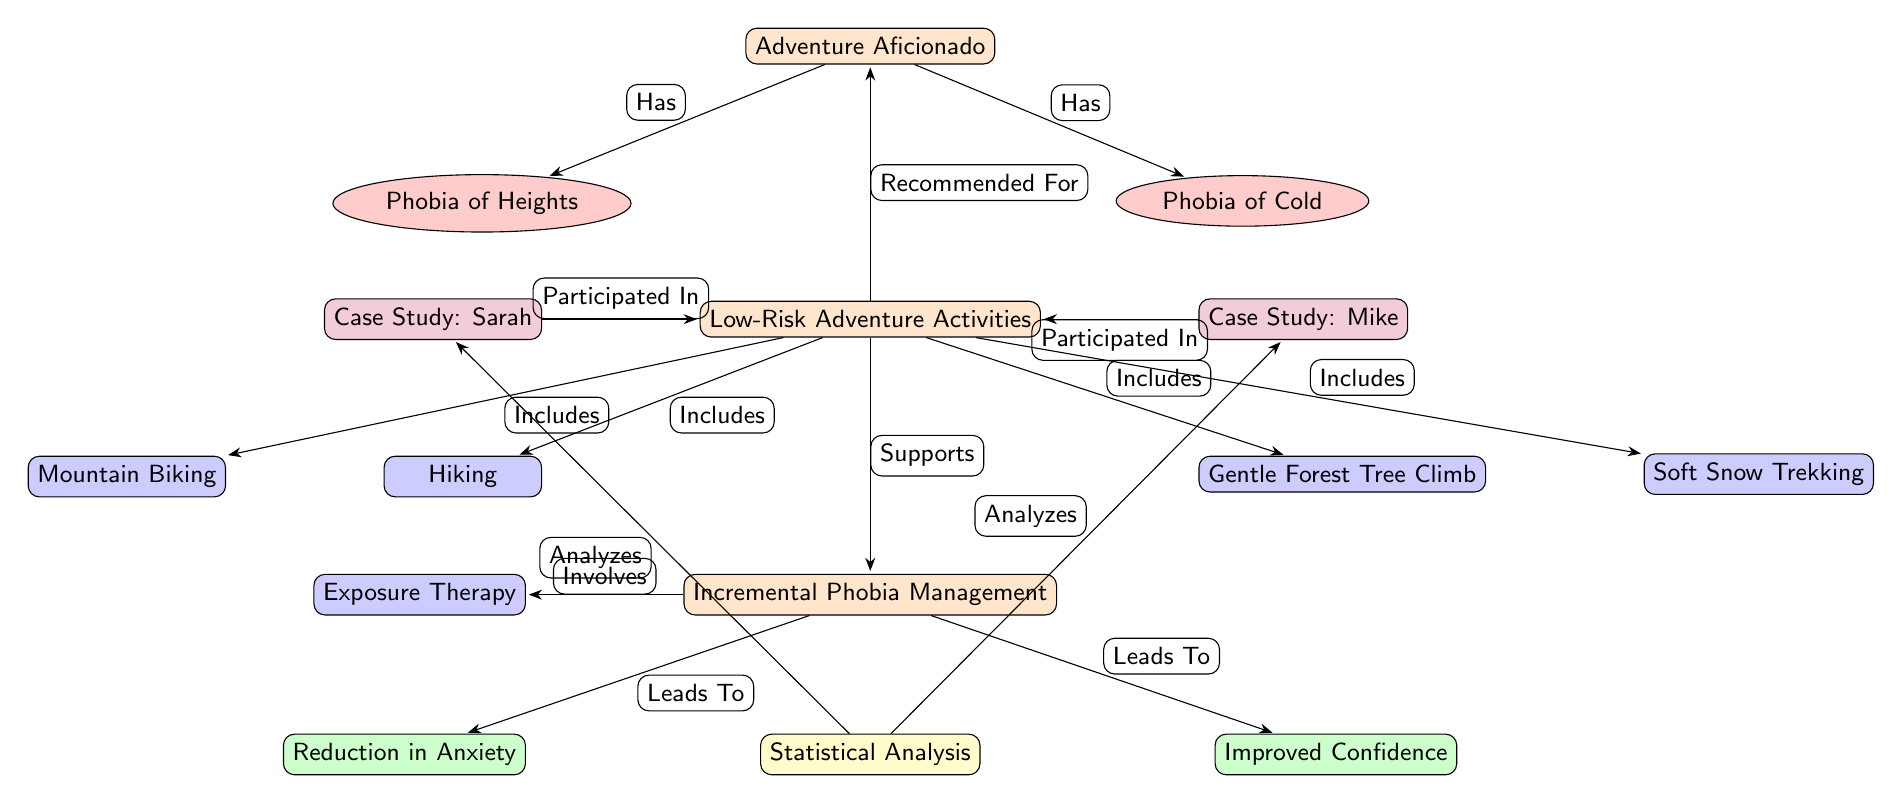What are the two phobias listed? The two phobias in the diagram are "Phobia of Heights" and "Phobia of Cold." These are directly found in the diagram below the node for "Adventure Aficionado."
Answer: Phobia of Heights, Phobia of Cold How many low-risk adventure activities are included? The diagram lists four low-risk adventure activities: Hiking, Mountain Biking, Gentle Forest Tree Climb, and Soft Snow Trekking. These activities are connected to the node for "Low-Risk Adventure Activities."
Answer: 4 What outcome results from Incremental Phobia Management? The outcomes listed under "Incremental Phobia Management" are "Reduction in Anxiety" and "Improved Confidence," both of which stem from this main node.
Answer: Reduction in Anxiety, Improved Confidence Which case study participated in low-risk adventure activities? Both case studies, "Sarah" and "Mike," are shown as having participated in "Low-Risk Adventure Activities," indicated by the edges connecting these nodes.
Answer: Sarah, Mike What does the statistical analysis analyze? The "Statistical Analysis" node in the diagram specifically analyzes the case studies of Sarah and Mike, as indicated by the incoming edges from those case study nodes to the analysis node.
Answer: Case Study: Sarah, Case Study: Mike How does Incremental Phobia Management relate to Exposure Therapy? "Incremental Phobia Management" involves "Exposure Therapy," which is indicated by a directed edge connecting these two nodes in the diagram. This implies that Exposure Therapy is a component of managing phobias incrementally.
Answer: Involves What recommendations are made regarding low-risk adventure activities? The diagram states that these activities are "Recommended For" the "Adventure Aficionado," connecting the nodes across the diagram.
Answer: Recommended For Which edge leads from Incremental Phobia Management to outcomes? The edges leading from the "Incremental Phobia Management" node lead to "Reduction in Anxiety" and "Improved Confidence," indicating the outcomes derived from this management strategy. Both outcomes show a direct result of the management process.
Answer: Leads To 